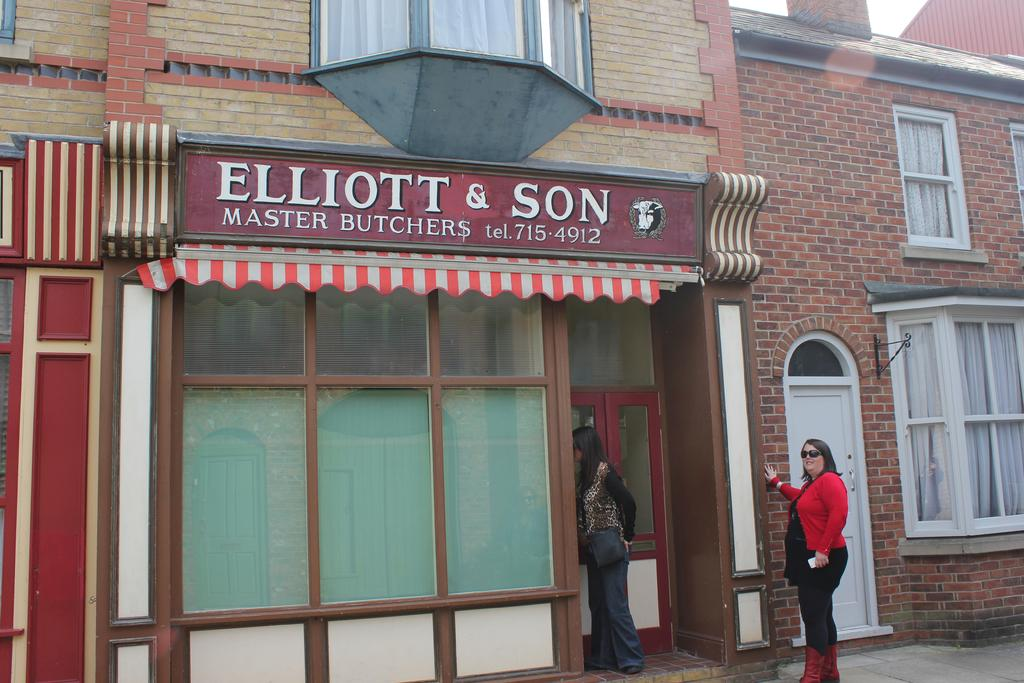What is located at the bottom of the image? There are people standing at the bottom of the image. What can be seen behind the people in the image? There are buildings visible behind the people. What type of baseball equipment can be seen in the image? There is no baseball equipment present in the image. What is the weight of the people standing at the bottom of the image? The weight of the people cannot be determined from the image alone. 